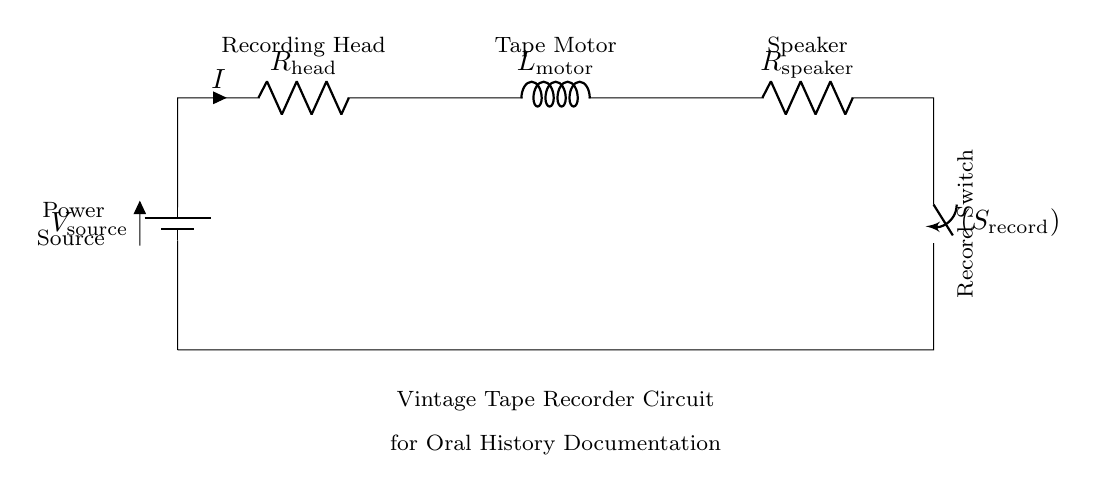What is the voltage source in the circuit? The voltage source is indicated as V_source in the circuit diagram, which is typically a battery providing the necessary voltage for operation.
Answer: V_source What type of components are present in this circuit? The components in the circuit include a battery, resistors, an inductor, and a switch, which are used to perform specific functions such as power supply, current limiting, magnetic control, and circuit opening/closing.
Answer: Battery, resistors, inductor, switch What is the function of the recording head? The recording head, labeled in the circuit as R_head, is responsible for capturing audio signals during the recording process in the tape recorder.
Answer: Capturing audio signals How does the current flow in this series circuit? In a series circuit, current flows through each component sequentially. Starting from the voltage source, it passes through the recording head, the tape motor, the speaker, and finally the switch, forming one continuous path.
Answer: Sequentially through all components What happens when the record switch is closed? Closing the record switch connects the circuit, allowing current to flow from the battery through the other components, enabling the tape recorder to function properly and record audio.
Answer: The circuit becomes closed and functions What is the role of the tape motor? The tape motor, labeled as L_motor in the circuit, drives the movement of the tape across the recording head, allowing for playback and recording of audio.
Answer: Drives tape movement 